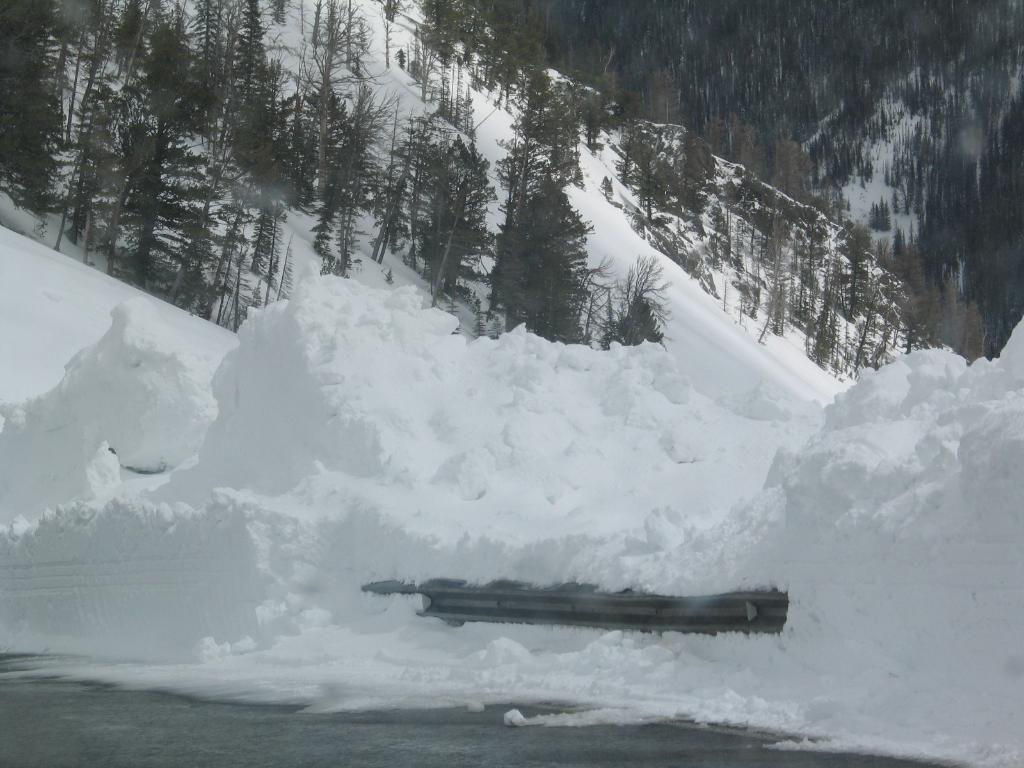What is present at the bottom of the image? There is snow at the bottom of the image. What geographical feature can be seen in the image? There is a mountain in the image. How is the mountain affected by the snow? The mountain has snow on it. What type of vegetation is present in the snow? There are trees in the snow. What time of day is indicated by the button on the mountain? There is no button present in the image, and therefore no indication of time. 